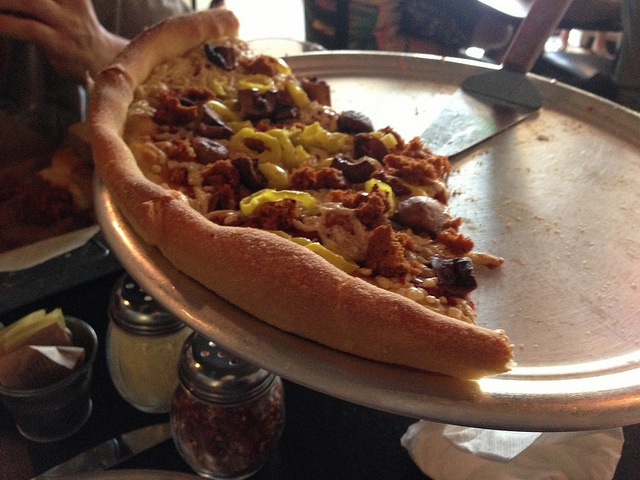Describe the objects in this image and their specific colors. I can see pizza in maroon, black, and brown tones, chair in maroon, gray, black, and white tones, bottle in maroon, black, and gray tones, bottle in maroon, black, and gray tones, and cup in maroon, black, gray, and darkgray tones in this image. 